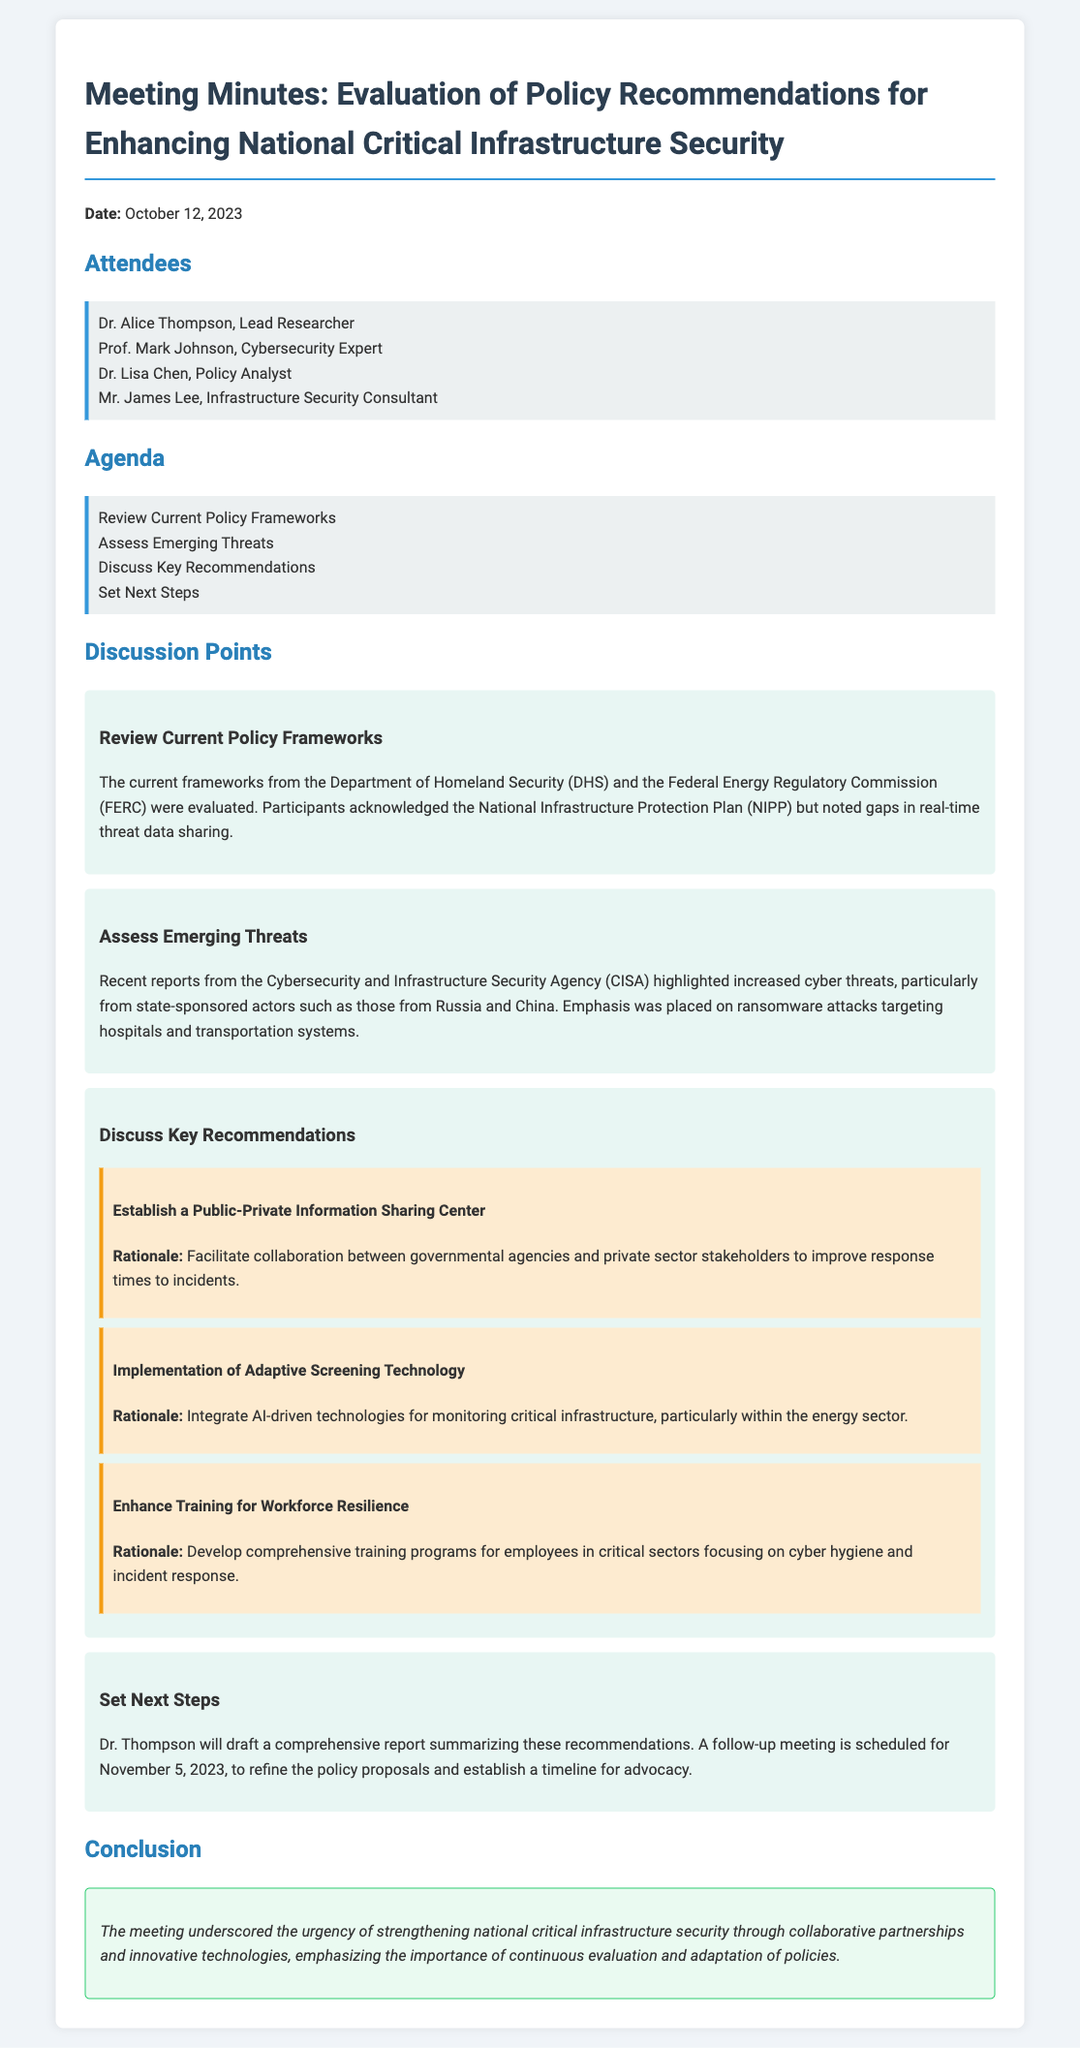What is the date of the meeting? The date of the meeting is explicitly stated in the document.
Answer: October 12, 2023 Who is the Lead Researcher attending the meeting? The document provides a list of attendees and identifies the Lead Researcher.
Answer: Dr. Alice Thompson What agency highlighted increased cyber threats? The document mentions a specific agency that reported on emerging threats.
Answer: Cybersecurity and Infrastructure Security Agency (CISA) What is one key recommendation discussed in the meeting? There are several recommendations listed in the document, and any of them would suffice.
Answer: Establish a Public-Private Information Sharing Center When is the follow-up meeting scheduled? The document specifies the date of the next meeting for refining policy proposals.
Answer: November 5, 2023 What was noted as a gap in current policy frameworks? The discussion point mentions a specific gap related to data.
Answer: Real-time threat data sharing What is the purpose of developing comprehensive training programs? The document indicates a specific focus for the training programs mentioned in the recommendations.
Answer: Cyber hygiene and incident response What color is used to highlight the conclusion section? The document describes the background color of the conclusion section.
Answer: Light green 